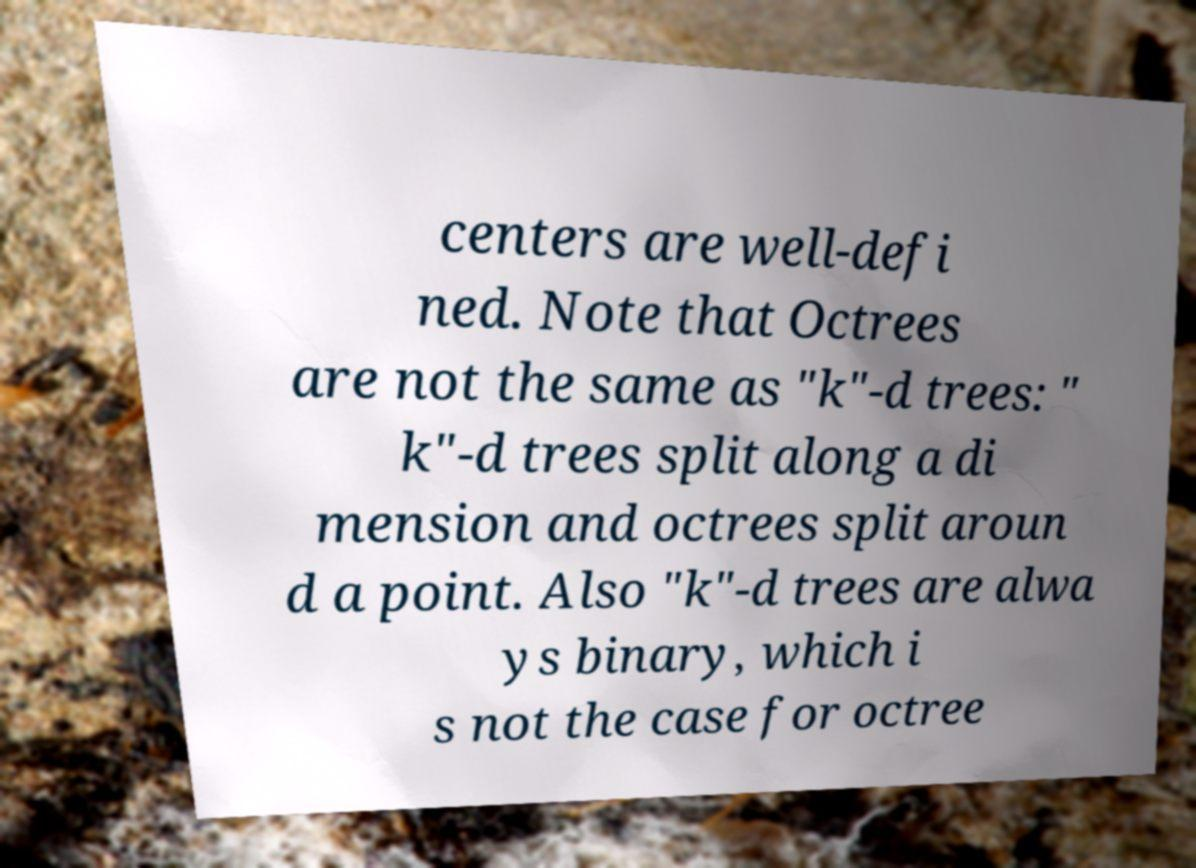There's text embedded in this image that I need extracted. Can you transcribe it verbatim? centers are well-defi ned. Note that Octrees are not the same as "k"-d trees: " k"-d trees split along a di mension and octrees split aroun d a point. Also "k"-d trees are alwa ys binary, which i s not the case for octree 